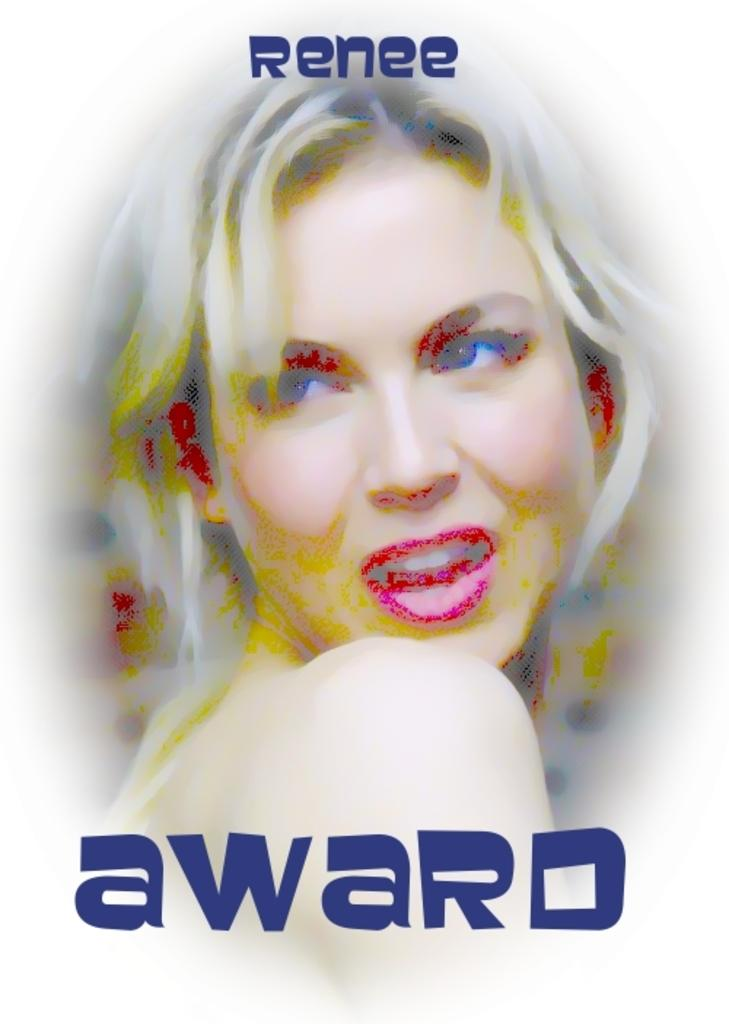Who is present in the image? There is a woman in the image. What can be seen in addition to the woman? There is text in dark blue color in the image. What type of wine is the woman holding in the image? There is no wine present in the image; it only features a woman and text in dark blue color. Can you see a cat in the image? There is no cat present in the image. 